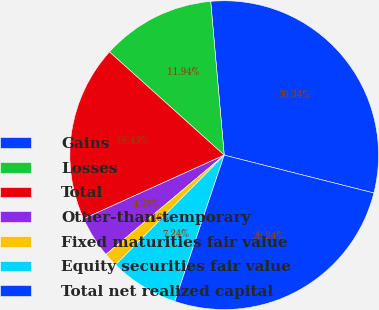<chart> <loc_0><loc_0><loc_500><loc_500><pie_chart><fcel>Gains<fcel>Losses<fcel>Total<fcel>Other-than-temporary<fcel>Fixed maturities fair value<fcel>Equity securities fair value<fcel>Total net realized capital<nl><fcel>30.34%<fcel>11.94%<fcel>18.43%<fcel>4.35%<fcel>1.46%<fcel>7.24%<fcel>26.24%<nl></chart> 